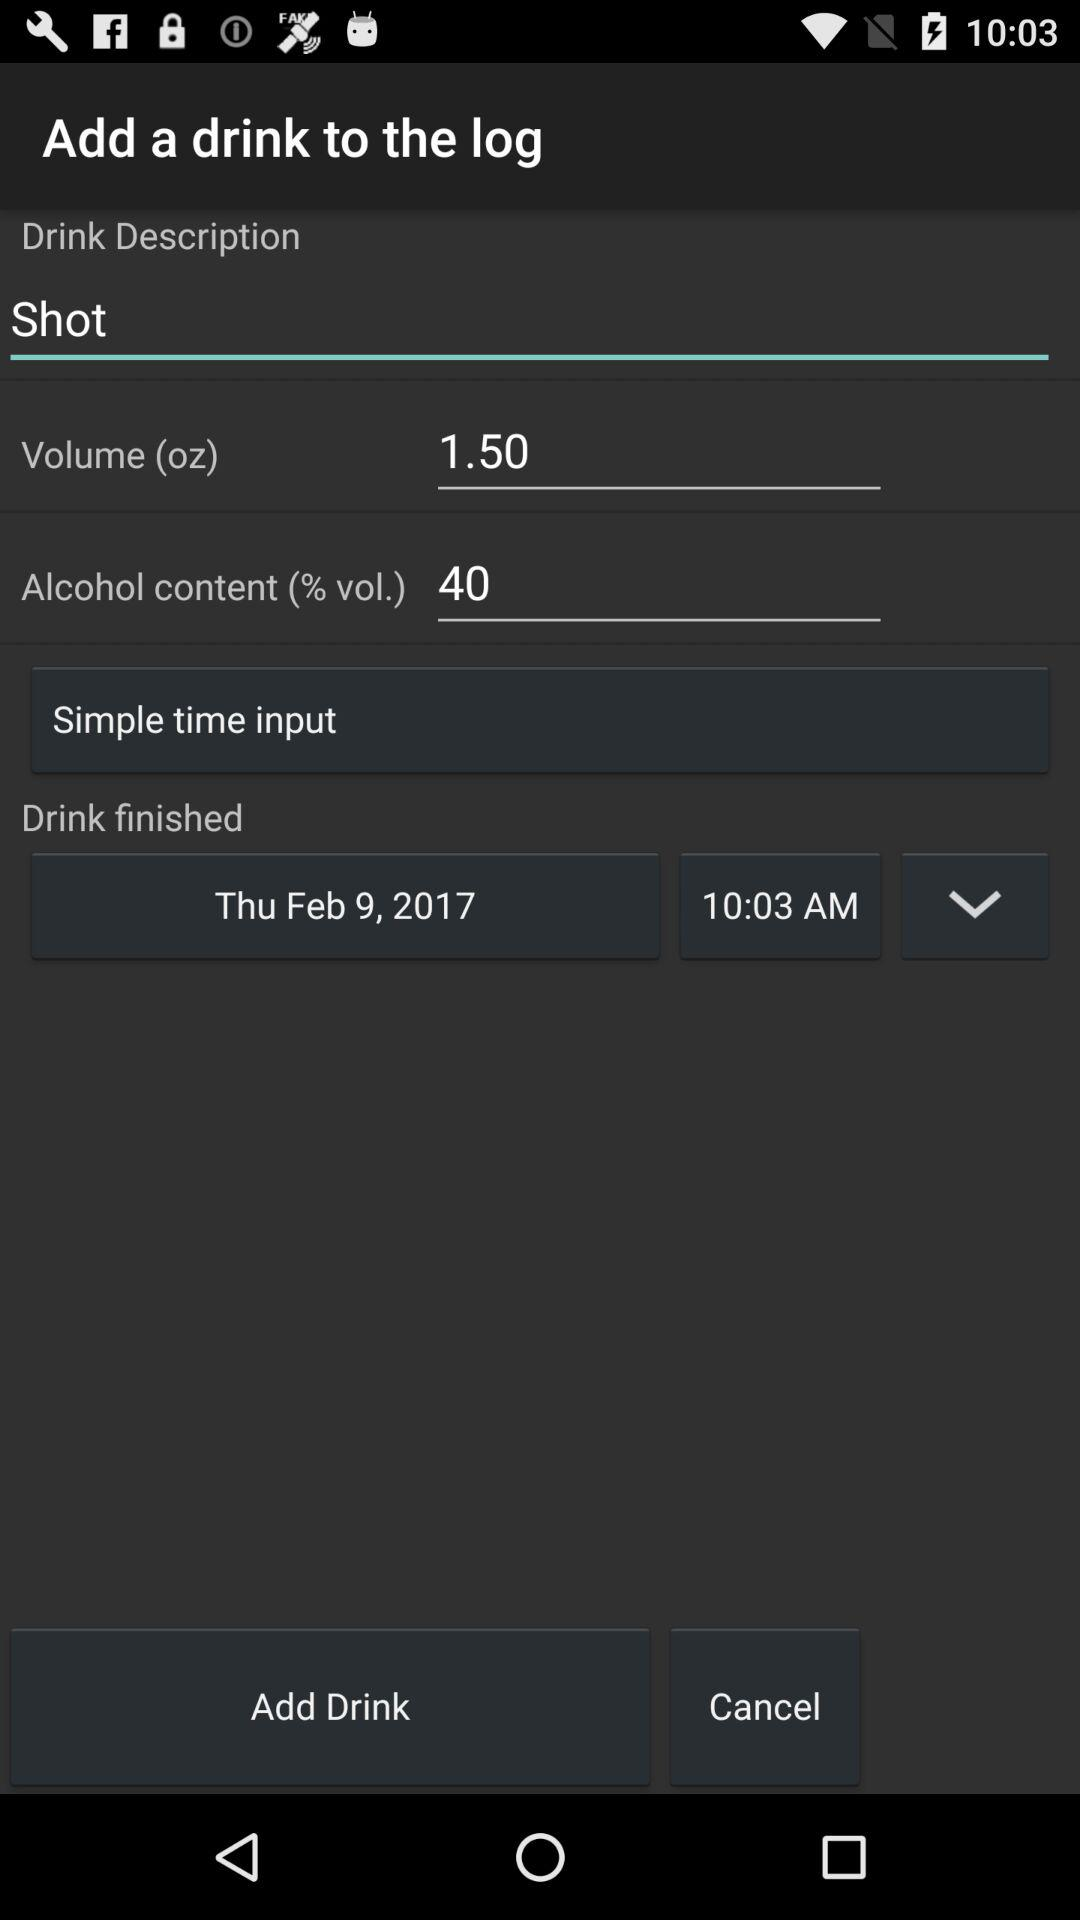What is the shown volume percentage of alcohol? The shown volume percentage of alcohol is 40. 